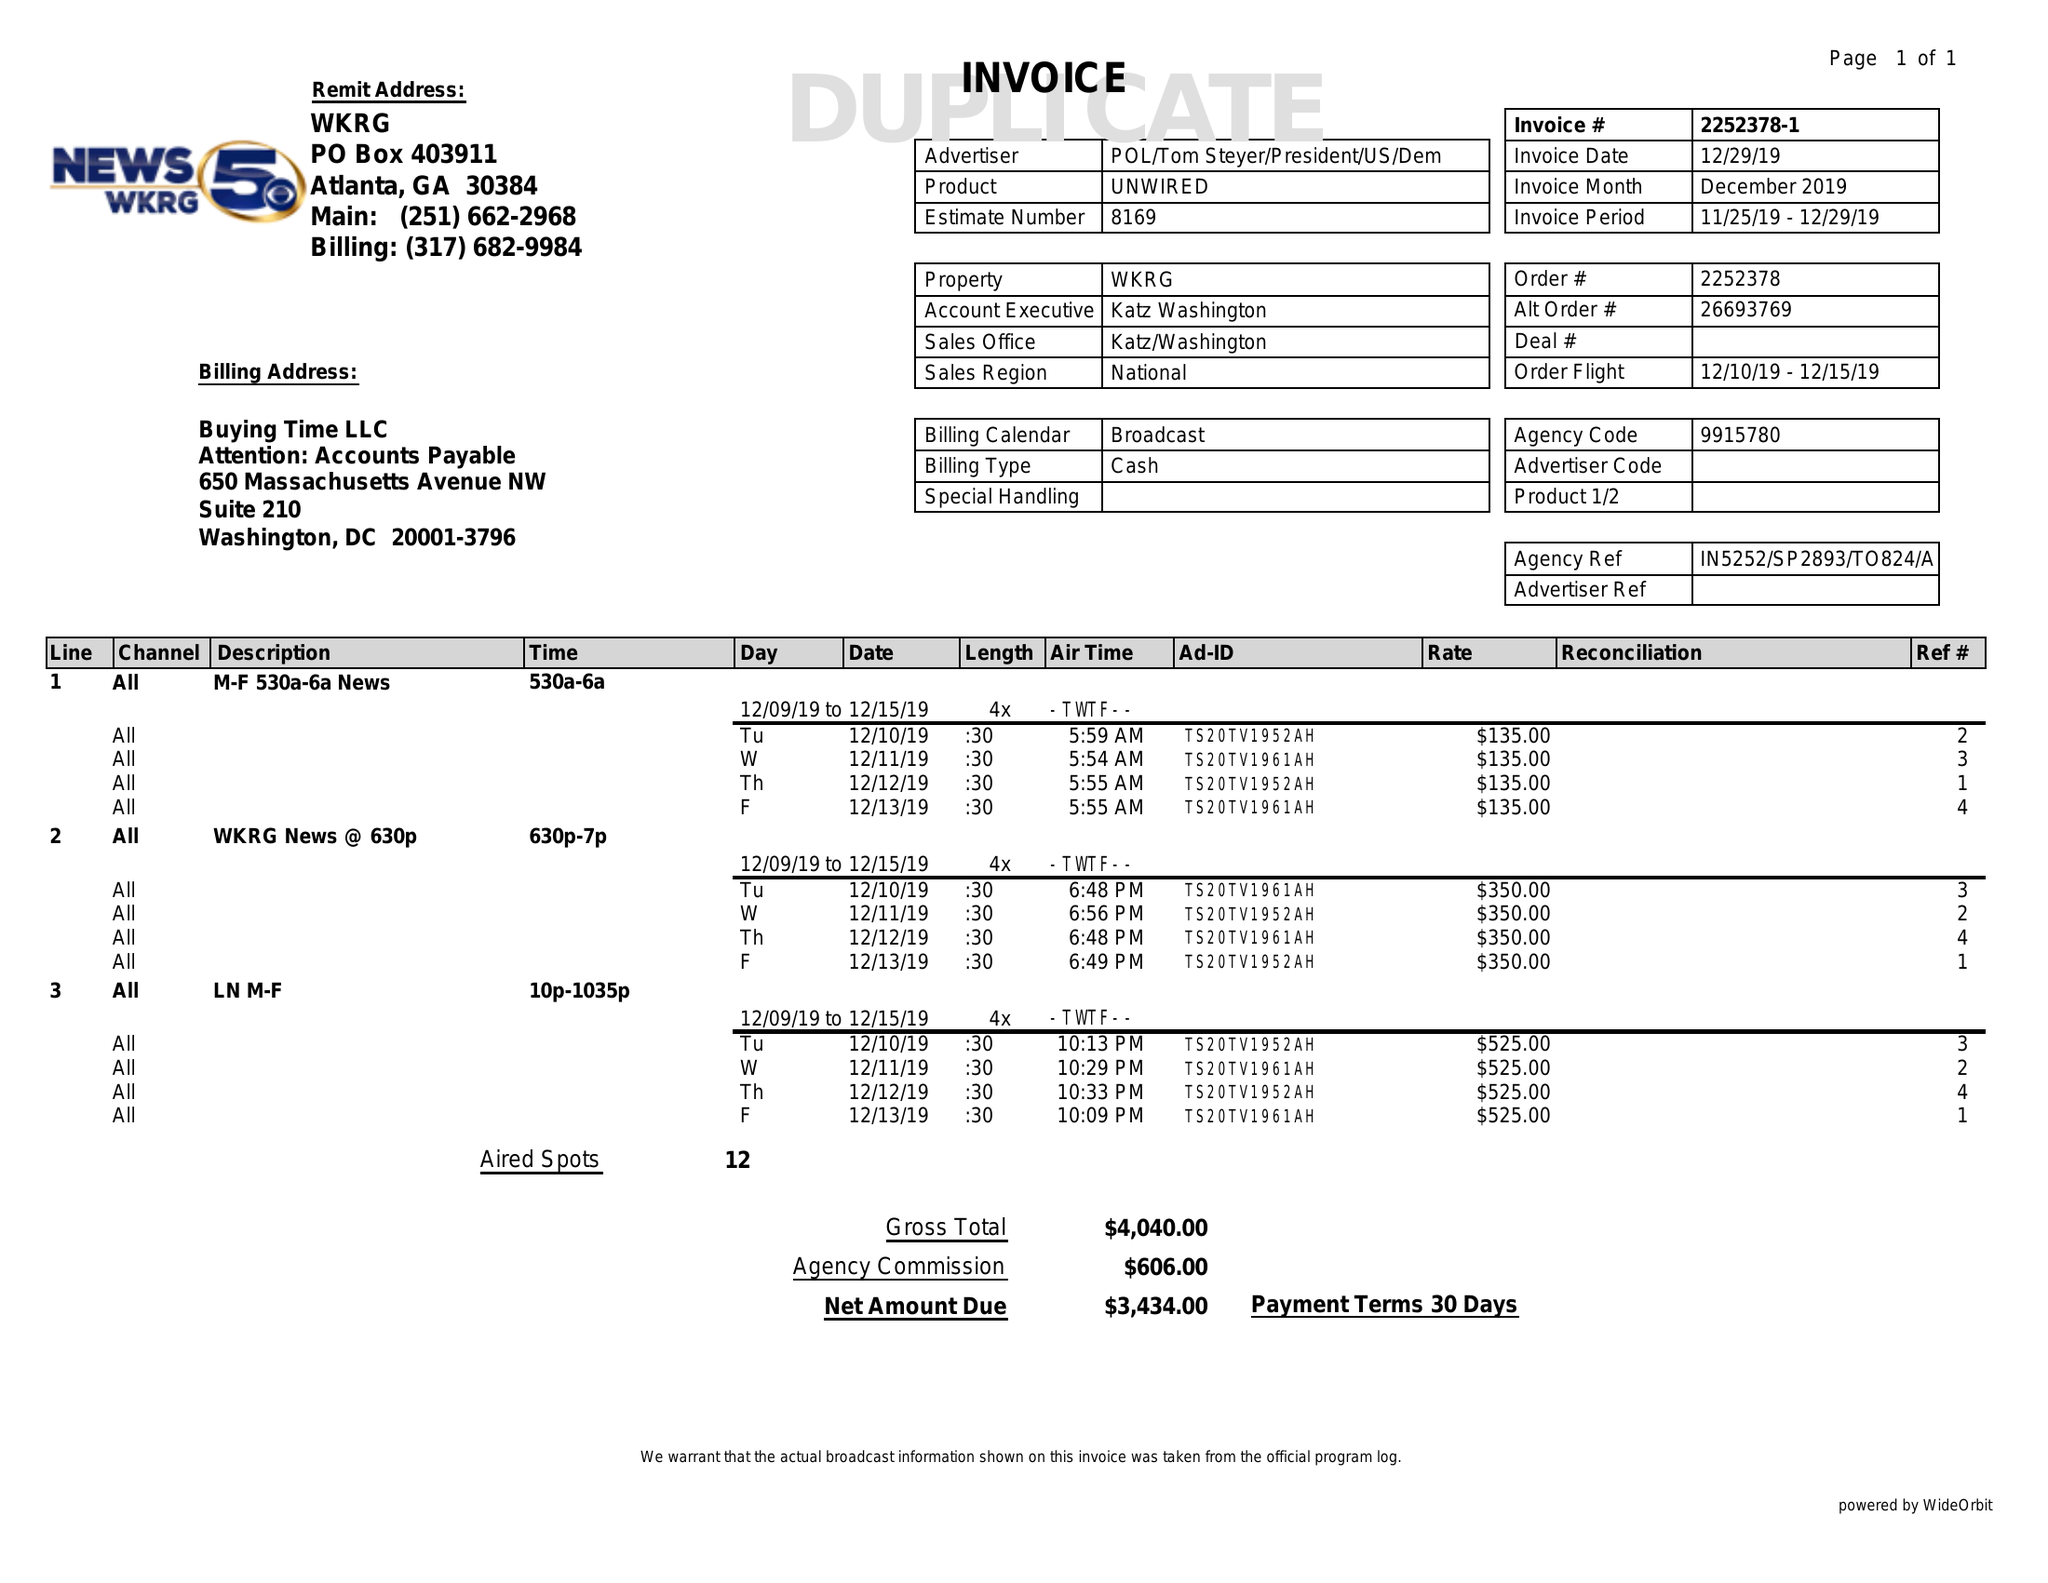What is the value for the advertiser?
Answer the question using a single word or phrase. POL/TOMSTEYER/PRESIDENT/US/DEM 